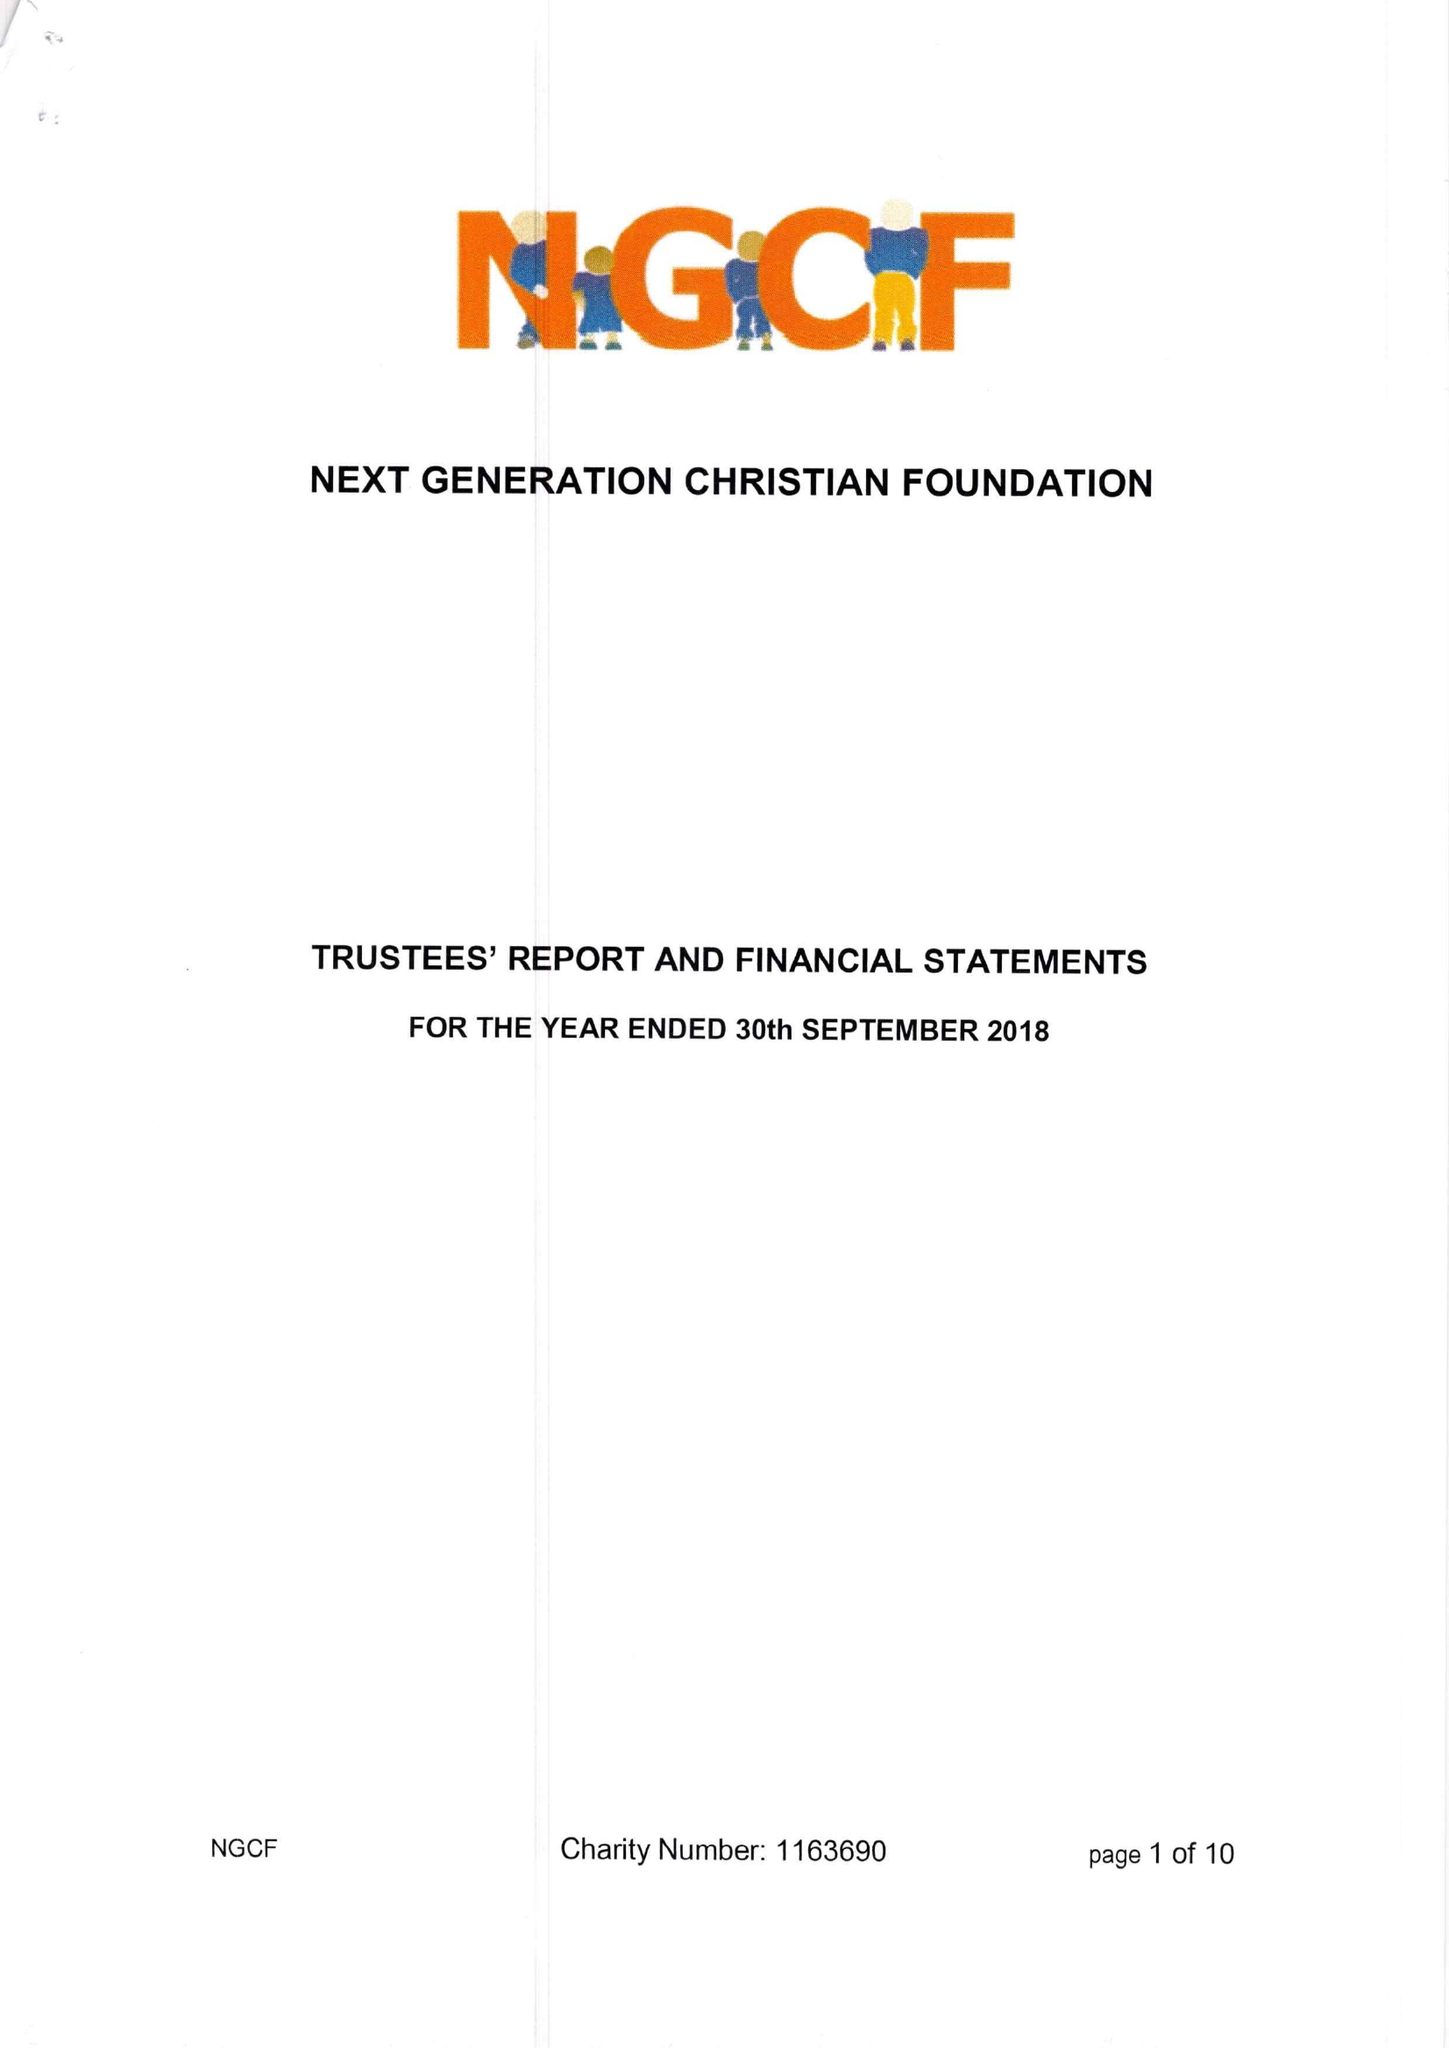What is the value for the spending_annually_in_british_pounds?
Answer the question using a single word or phrase. 4375.00 